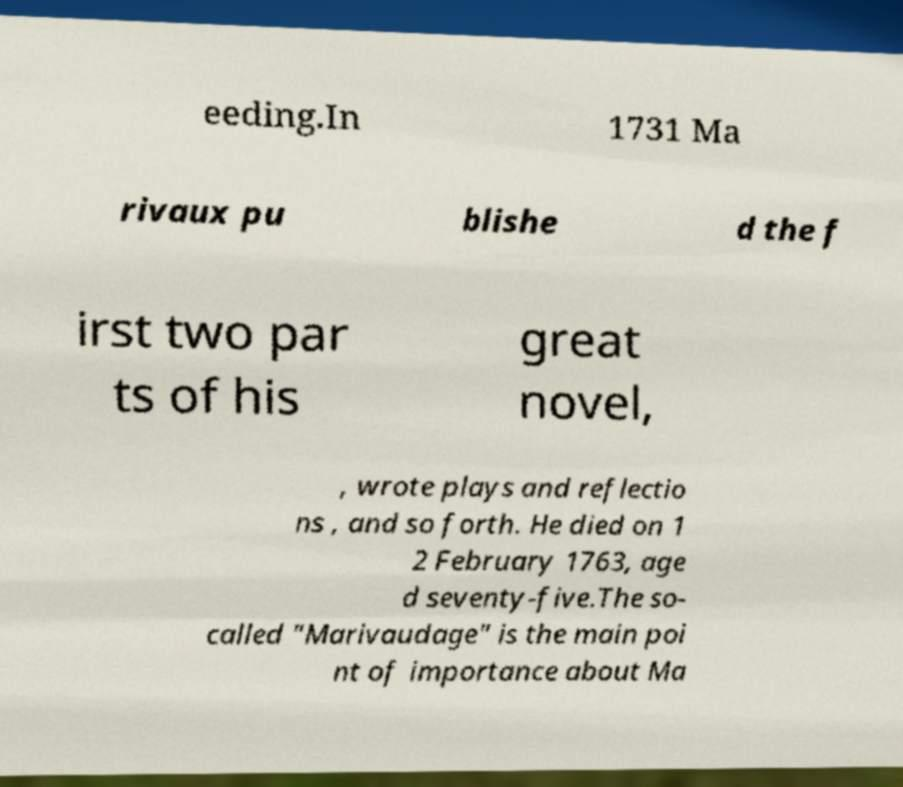For documentation purposes, I need the text within this image transcribed. Could you provide that? eeding.In 1731 Ma rivaux pu blishe d the f irst two par ts of his great novel, , wrote plays and reflectio ns , and so forth. He died on 1 2 February 1763, age d seventy-five.The so- called "Marivaudage" is the main poi nt of importance about Ma 